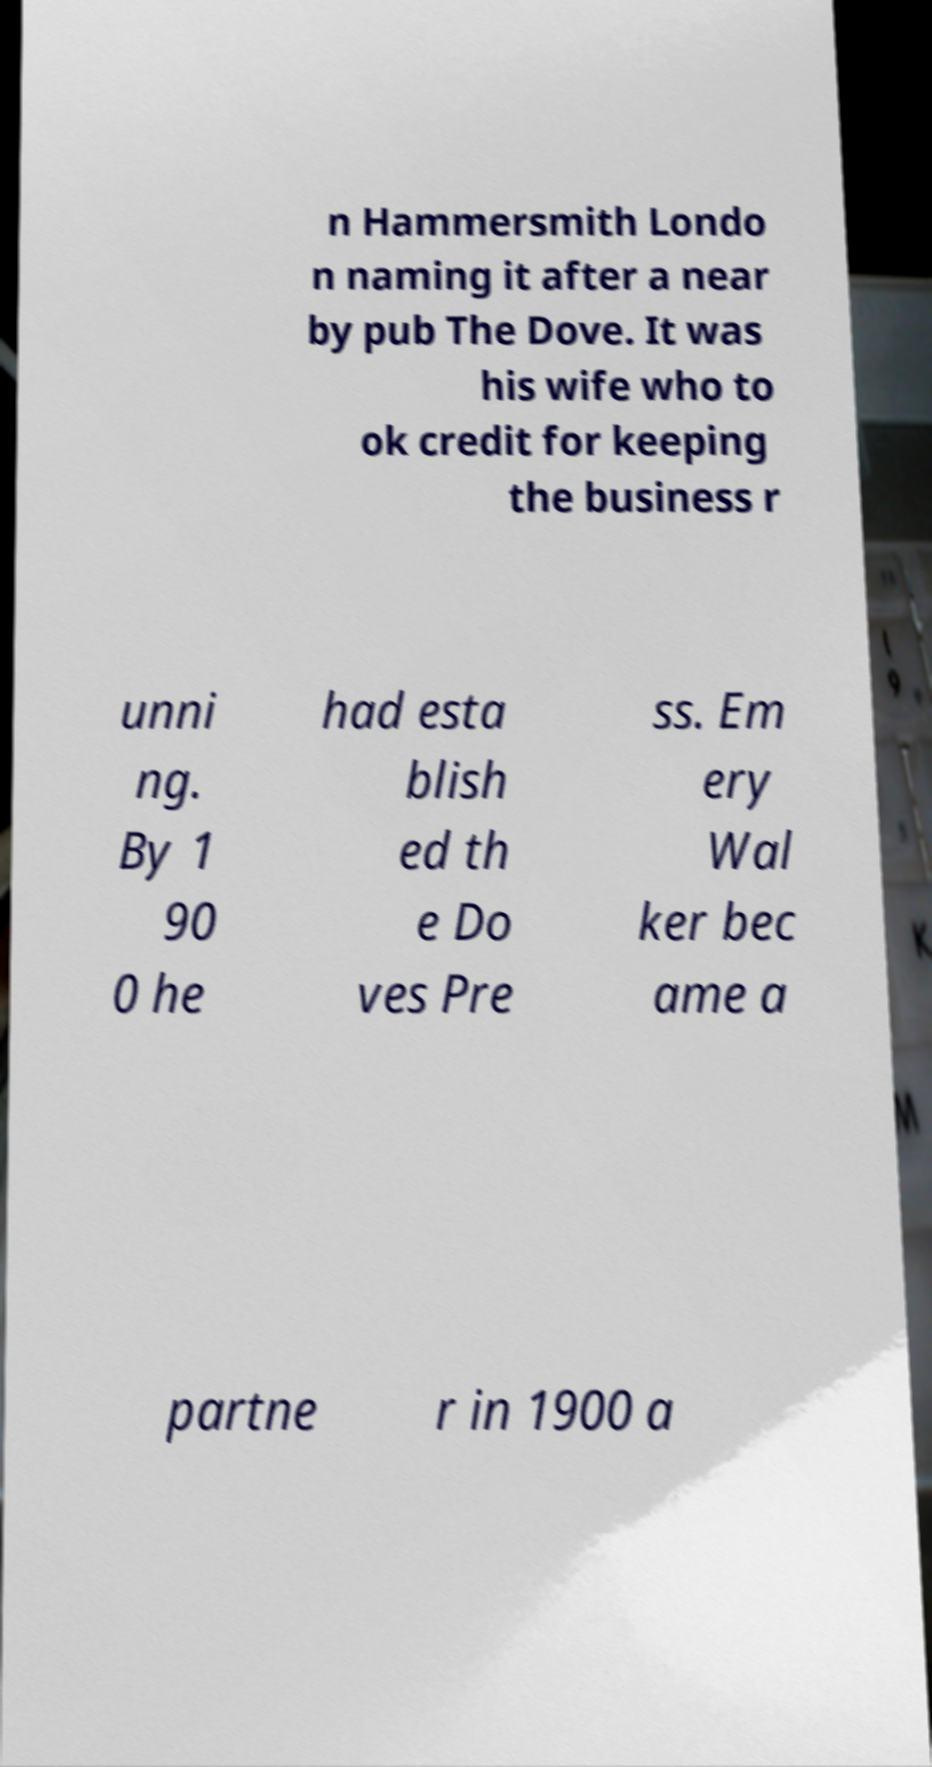Could you extract and type out the text from this image? n Hammersmith Londo n naming it after a near by pub The Dove. It was his wife who to ok credit for keeping the business r unni ng. By 1 90 0 he had esta blish ed th e Do ves Pre ss. Em ery Wal ker bec ame a partne r in 1900 a 